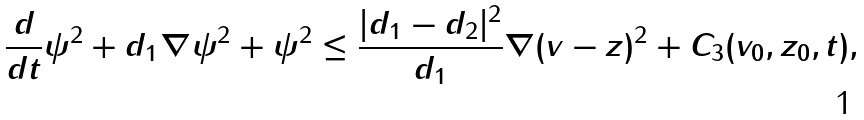Convert formula to latex. <formula><loc_0><loc_0><loc_500><loc_500>\frac { d } { d t } \| \psi \| ^ { 2 } + d _ { 1 } \| \nabla \psi \| ^ { 2 } + \| \psi \| ^ { 2 } \leq \frac { | d _ { 1 } - d _ { 2 } | ^ { 2 } } { d _ { 1 } } \| \nabla ( v - z ) \| ^ { 2 } + C _ { 3 } ( v _ { 0 } , z _ { 0 } , t ) ,</formula> 